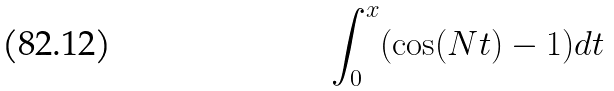<formula> <loc_0><loc_0><loc_500><loc_500>\int _ { 0 } ^ { x } ( \cos ( N t ) - 1 ) d t</formula> 